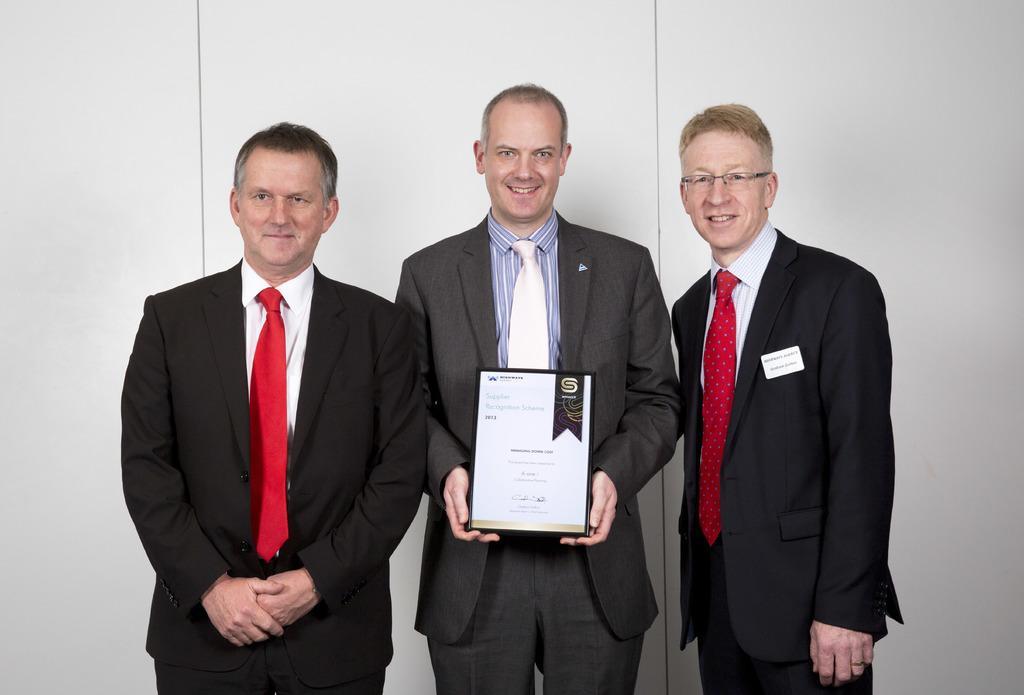How would you summarize this image in a sentence or two? There are people standing and smiling and this man holding a frame,behind these people we can see white wall. 